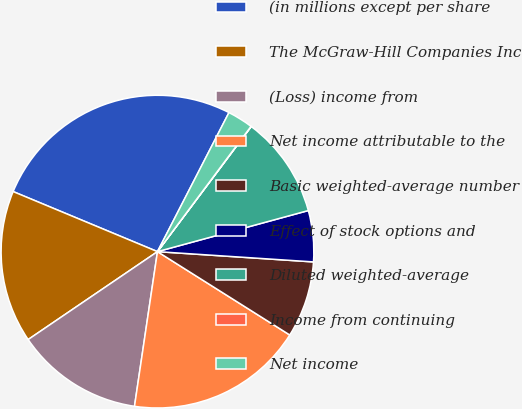<chart> <loc_0><loc_0><loc_500><loc_500><pie_chart><fcel>(in millions except per share<fcel>The McGraw-Hill Companies Inc<fcel>(Loss) income from<fcel>Net income attributable to the<fcel>Basic weighted-average number<fcel>Effect of stock options and<fcel>Diluted weighted-average<fcel>Income from continuing<fcel>Net income<nl><fcel>26.28%<fcel>15.78%<fcel>13.15%<fcel>18.4%<fcel>7.9%<fcel>5.28%<fcel>10.53%<fcel>0.03%<fcel>2.65%<nl></chart> 